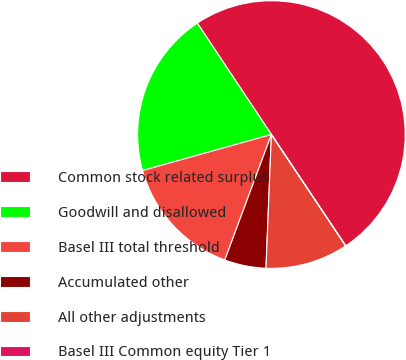<chart> <loc_0><loc_0><loc_500><loc_500><pie_chart><fcel>Common stock related surplus<fcel>Goodwill and disallowed<fcel>Basel III total threshold<fcel>Accumulated other<fcel>All other adjustments<fcel>Basel III Common equity Tier 1<nl><fcel>49.97%<fcel>20.0%<fcel>15.0%<fcel>5.01%<fcel>10.01%<fcel>0.01%<nl></chart> 